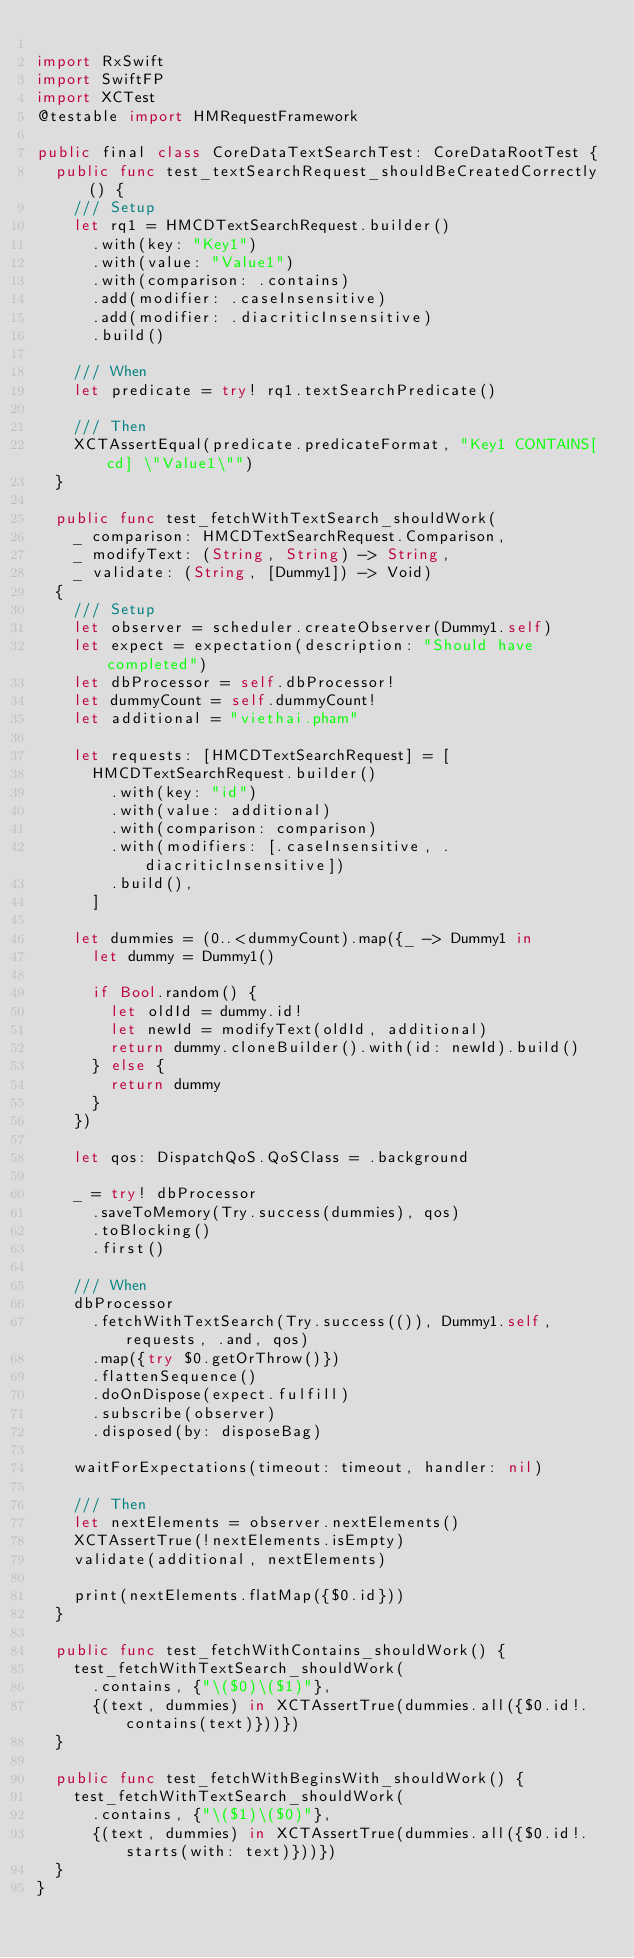<code> <loc_0><loc_0><loc_500><loc_500><_Swift_>
import RxSwift
import SwiftFP
import XCTest
@testable import HMRequestFramework

public final class CoreDataTextSearchTest: CoreDataRootTest {
  public func test_textSearchRequest_shouldBeCreatedCorrectly() {
    /// Setup
    let rq1 = HMCDTextSearchRequest.builder()
      .with(key: "Key1")
      .with(value: "Value1")
      .with(comparison: .contains)
      .add(modifier: .caseInsensitive)
      .add(modifier: .diacriticInsensitive)
      .build()

    /// When
    let predicate = try! rq1.textSearchPredicate()

    /// Then
    XCTAssertEqual(predicate.predicateFormat, "Key1 CONTAINS[cd] \"Value1\"")
  }

  public func test_fetchWithTextSearch_shouldWork(
    _ comparison: HMCDTextSearchRequest.Comparison,
    _ modifyText: (String, String) -> String,
    _ validate: (String, [Dummy1]) -> Void)
  {
    /// Setup
    let observer = scheduler.createObserver(Dummy1.self)
    let expect = expectation(description: "Should have completed")
    let dbProcessor = self.dbProcessor!
    let dummyCount = self.dummyCount!
    let additional = "viethai.pham"

    let requests: [HMCDTextSearchRequest] = [
      HMCDTextSearchRequest.builder()
        .with(key: "id")
        .with(value: additional)
        .with(comparison: comparison)
        .with(modifiers: [.caseInsensitive, .diacriticInsensitive])
        .build(),
      ]

    let dummies = (0..<dummyCount).map({_ -> Dummy1 in
      let dummy = Dummy1()

      if Bool.random() {
        let oldId = dummy.id!
        let newId = modifyText(oldId, additional)
        return dummy.cloneBuilder().with(id: newId).build()
      } else {
        return dummy
      }
    })

    let qos: DispatchQoS.QoSClass = .background

    _ = try! dbProcessor
      .saveToMemory(Try.success(dummies), qos)
      .toBlocking()
      .first()

    /// When
    dbProcessor
      .fetchWithTextSearch(Try.success(()), Dummy1.self, requests, .and, qos)
      .map({try $0.getOrThrow()})
      .flattenSequence()
      .doOnDispose(expect.fulfill)
      .subscribe(observer)
      .disposed(by: disposeBag)

    waitForExpectations(timeout: timeout, handler: nil)

    /// Then
    let nextElements = observer.nextElements()
    XCTAssertTrue(!nextElements.isEmpty)
    validate(additional, nextElements)

    print(nextElements.flatMap({$0.id}))
  }

  public func test_fetchWithContains_shouldWork() {
    test_fetchWithTextSearch_shouldWork(
      .contains, {"\($0)\($1)"},
      {(text, dummies) in XCTAssertTrue(dummies.all({$0.id!.contains(text)}))})
  }

  public func test_fetchWithBeginsWith_shouldWork() {
    test_fetchWithTextSearch_shouldWork(
      .contains, {"\($1)\($0)"},
      {(text, dummies) in XCTAssertTrue(dummies.all({$0.id!.starts(with: text)}))})
  }
}
</code> 